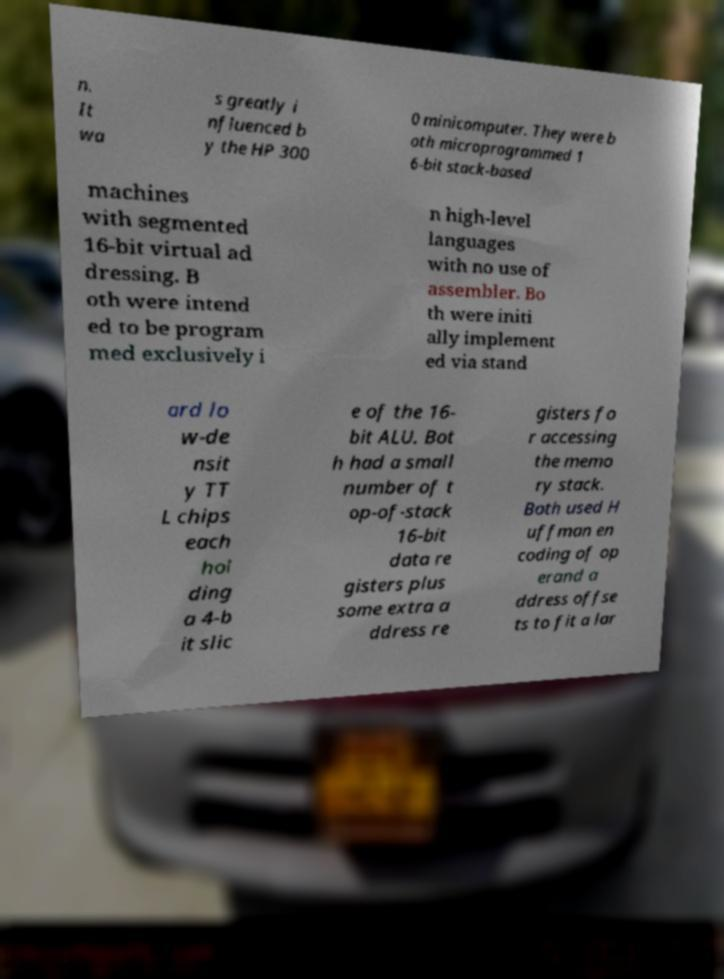Can you read and provide the text displayed in the image?This photo seems to have some interesting text. Can you extract and type it out for me? n. It wa s greatly i nfluenced b y the HP 300 0 minicomputer. They were b oth microprogrammed 1 6-bit stack-based machines with segmented 16-bit virtual ad dressing. B oth were intend ed to be program med exclusively i n high-level languages with no use of assembler. Bo th were initi ally implement ed via stand ard lo w-de nsit y TT L chips each hol ding a 4-b it slic e of the 16- bit ALU. Bot h had a small number of t op-of-stack 16-bit data re gisters plus some extra a ddress re gisters fo r accessing the memo ry stack. Both used H uffman en coding of op erand a ddress offse ts to fit a lar 